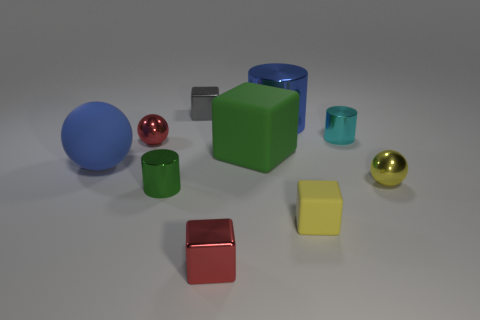Subtract all small blocks. How many blocks are left? 1 Subtract 2 cubes. How many cubes are left? 2 Subtract all green cylinders. How many cylinders are left? 2 Subtract all brown cubes. How many brown balls are left? 0 Subtract all brown shiny objects. Subtract all red things. How many objects are left? 8 Add 4 red metallic things. How many red metallic things are left? 6 Add 6 cyan objects. How many cyan objects exist? 7 Subtract 0 cyan blocks. How many objects are left? 10 Subtract all blocks. How many objects are left? 6 Subtract all blue spheres. Subtract all yellow cylinders. How many spheres are left? 2 